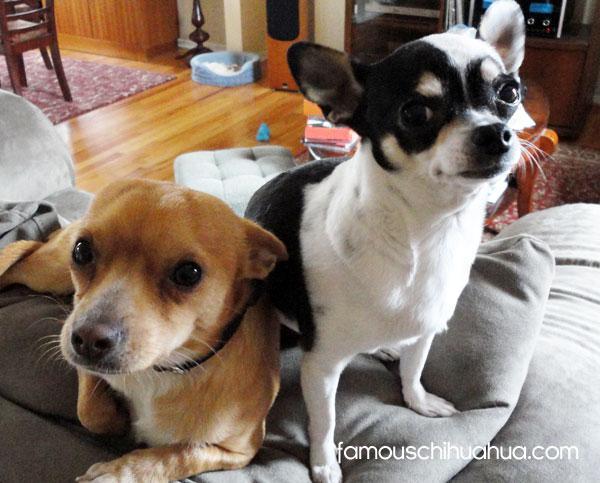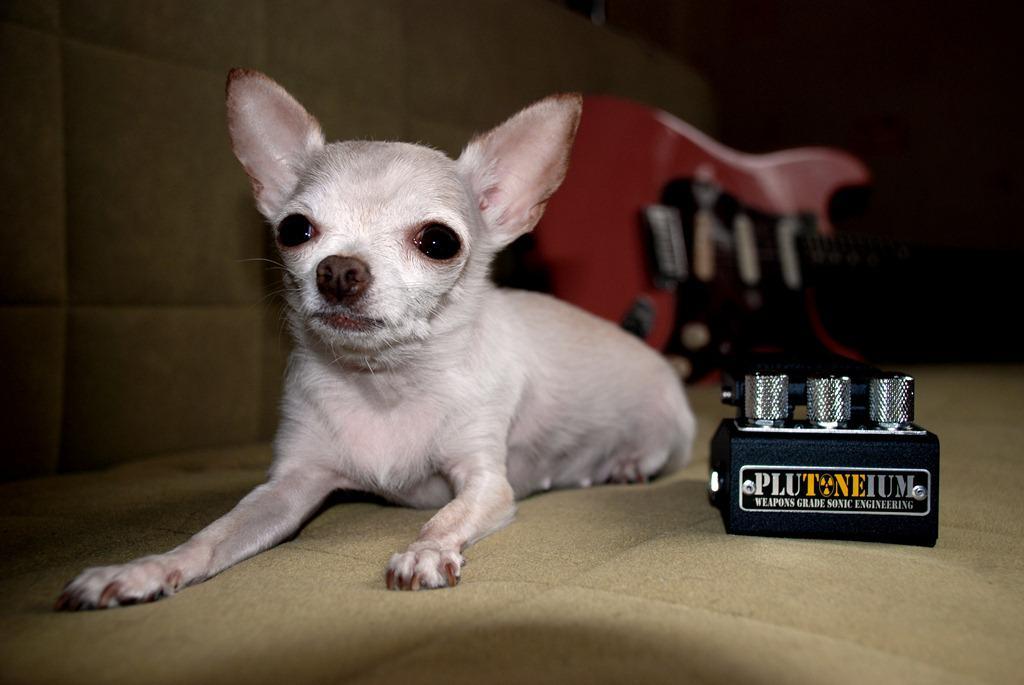The first image is the image on the left, the second image is the image on the right. For the images shown, is this caption "An image shows two tan dogs with heads side-by-side and erect ears, and one is wearing a bright blue collar." true? Answer yes or no. No. The first image is the image on the left, the second image is the image on the right. Evaluate the accuracy of this statement regarding the images: "One of the dogs is wearing a pink collar.". Is it true? Answer yes or no. No. 